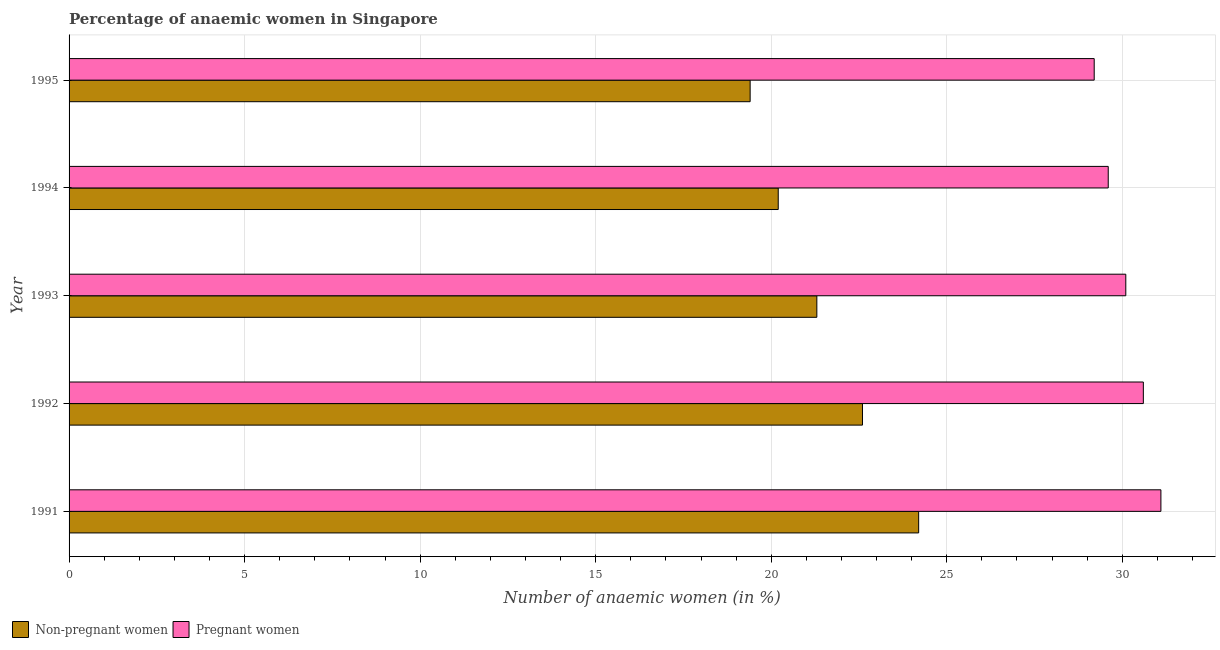How many different coloured bars are there?
Ensure brevity in your answer.  2. How many groups of bars are there?
Your answer should be very brief. 5. How many bars are there on the 4th tick from the bottom?
Offer a very short reply. 2. What is the label of the 4th group of bars from the top?
Your answer should be very brief. 1992. What is the percentage of non-pregnant anaemic women in 1995?
Offer a terse response. 19.4. Across all years, what is the maximum percentage of pregnant anaemic women?
Ensure brevity in your answer.  31.1. What is the total percentage of pregnant anaemic women in the graph?
Offer a very short reply. 150.6. What is the difference between the percentage of non-pregnant anaemic women in 1993 and that in 1995?
Your response must be concise. 1.9. What is the difference between the percentage of non-pregnant anaemic women in 1993 and the percentage of pregnant anaemic women in 1995?
Provide a short and direct response. -7.9. What is the average percentage of non-pregnant anaemic women per year?
Offer a very short reply. 21.54. What is the ratio of the percentage of non-pregnant anaemic women in 1992 to that in 1994?
Keep it short and to the point. 1.12. What is the difference between the highest and the second highest percentage of pregnant anaemic women?
Your answer should be compact. 0.5. What is the difference between the highest and the lowest percentage of non-pregnant anaemic women?
Your answer should be very brief. 4.8. What does the 1st bar from the top in 1994 represents?
Give a very brief answer. Pregnant women. What does the 1st bar from the bottom in 1992 represents?
Give a very brief answer. Non-pregnant women. Does the graph contain any zero values?
Provide a short and direct response. No. Where does the legend appear in the graph?
Make the answer very short. Bottom left. How many legend labels are there?
Offer a very short reply. 2. How are the legend labels stacked?
Keep it short and to the point. Horizontal. What is the title of the graph?
Your response must be concise. Percentage of anaemic women in Singapore. Does "Fixed telephone" appear as one of the legend labels in the graph?
Give a very brief answer. No. What is the label or title of the X-axis?
Ensure brevity in your answer.  Number of anaemic women (in %). What is the label or title of the Y-axis?
Ensure brevity in your answer.  Year. What is the Number of anaemic women (in %) in Non-pregnant women in 1991?
Give a very brief answer. 24.2. What is the Number of anaemic women (in %) in Pregnant women in 1991?
Ensure brevity in your answer.  31.1. What is the Number of anaemic women (in %) in Non-pregnant women in 1992?
Make the answer very short. 22.6. What is the Number of anaemic women (in %) in Pregnant women in 1992?
Provide a short and direct response. 30.6. What is the Number of anaemic women (in %) of Non-pregnant women in 1993?
Your response must be concise. 21.3. What is the Number of anaemic women (in %) of Pregnant women in 1993?
Provide a succinct answer. 30.1. What is the Number of anaemic women (in %) of Non-pregnant women in 1994?
Provide a succinct answer. 20.2. What is the Number of anaemic women (in %) in Pregnant women in 1994?
Your answer should be very brief. 29.6. What is the Number of anaemic women (in %) of Pregnant women in 1995?
Your answer should be very brief. 29.2. Across all years, what is the maximum Number of anaemic women (in %) of Non-pregnant women?
Ensure brevity in your answer.  24.2. Across all years, what is the maximum Number of anaemic women (in %) in Pregnant women?
Your answer should be very brief. 31.1. Across all years, what is the minimum Number of anaemic women (in %) in Pregnant women?
Offer a terse response. 29.2. What is the total Number of anaemic women (in %) of Non-pregnant women in the graph?
Ensure brevity in your answer.  107.7. What is the total Number of anaemic women (in %) in Pregnant women in the graph?
Your answer should be very brief. 150.6. What is the difference between the Number of anaemic women (in %) in Non-pregnant women in 1991 and that in 1992?
Your answer should be compact. 1.6. What is the difference between the Number of anaemic women (in %) of Non-pregnant women in 1991 and that in 1993?
Offer a very short reply. 2.9. What is the difference between the Number of anaemic women (in %) in Non-pregnant women in 1991 and that in 1994?
Your answer should be compact. 4. What is the difference between the Number of anaemic women (in %) of Pregnant women in 1991 and that in 1995?
Make the answer very short. 1.9. What is the difference between the Number of anaemic women (in %) in Pregnant women in 1992 and that in 1993?
Your answer should be compact. 0.5. What is the difference between the Number of anaemic women (in %) of Non-pregnant women in 1992 and that in 1995?
Your answer should be very brief. 3.2. What is the difference between the Number of anaemic women (in %) of Non-pregnant women in 1993 and that in 1995?
Keep it short and to the point. 1.9. What is the difference between the Number of anaemic women (in %) in Pregnant women in 1993 and that in 1995?
Your answer should be compact. 0.9. What is the difference between the Number of anaemic women (in %) in Non-pregnant women in 1994 and that in 1995?
Provide a short and direct response. 0.8. What is the difference between the Number of anaemic women (in %) of Pregnant women in 1994 and that in 1995?
Provide a short and direct response. 0.4. What is the difference between the Number of anaemic women (in %) of Non-pregnant women in 1991 and the Number of anaemic women (in %) of Pregnant women in 1995?
Provide a short and direct response. -5. What is the difference between the Number of anaemic women (in %) of Non-pregnant women in 1992 and the Number of anaemic women (in %) of Pregnant women in 1993?
Make the answer very short. -7.5. What is the difference between the Number of anaemic women (in %) of Non-pregnant women in 1992 and the Number of anaemic women (in %) of Pregnant women in 1994?
Provide a short and direct response. -7. What is the difference between the Number of anaemic women (in %) in Non-pregnant women in 1992 and the Number of anaemic women (in %) in Pregnant women in 1995?
Offer a very short reply. -6.6. What is the difference between the Number of anaemic women (in %) of Non-pregnant women in 1994 and the Number of anaemic women (in %) of Pregnant women in 1995?
Provide a succinct answer. -9. What is the average Number of anaemic women (in %) of Non-pregnant women per year?
Your answer should be compact. 21.54. What is the average Number of anaemic women (in %) in Pregnant women per year?
Keep it short and to the point. 30.12. In the year 1991, what is the difference between the Number of anaemic women (in %) of Non-pregnant women and Number of anaemic women (in %) of Pregnant women?
Your answer should be compact. -6.9. In the year 1992, what is the difference between the Number of anaemic women (in %) in Non-pregnant women and Number of anaemic women (in %) in Pregnant women?
Provide a short and direct response. -8. In the year 1994, what is the difference between the Number of anaemic women (in %) of Non-pregnant women and Number of anaemic women (in %) of Pregnant women?
Provide a succinct answer. -9.4. What is the ratio of the Number of anaemic women (in %) in Non-pregnant women in 1991 to that in 1992?
Keep it short and to the point. 1.07. What is the ratio of the Number of anaemic women (in %) in Pregnant women in 1991 to that in 1992?
Provide a short and direct response. 1.02. What is the ratio of the Number of anaemic women (in %) of Non-pregnant women in 1991 to that in 1993?
Offer a terse response. 1.14. What is the ratio of the Number of anaemic women (in %) in Pregnant women in 1991 to that in 1993?
Offer a very short reply. 1.03. What is the ratio of the Number of anaemic women (in %) in Non-pregnant women in 1991 to that in 1994?
Make the answer very short. 1.2. What is the ratio of the Number of anaemic women (in %) in Pregnant women in 1991 to that in 1994?
Keep it short and to the point. 1.05. What is the ratio of the Number of anaemic women (in %) of Non-pregnant women in 1991 to that in 1995?
Provide a short and direct response. 1.25. What is the ratio of the Number of anaemic women (in %) of Pregnant women in 1991 to that in 1995?
Make the answer very short. 1.07. What is the ratio of the Number of anaemic women (in %) in Non-pregnant women in 1992 to that in 1993?
Offer a terse response. 1.06. What is the ratio of the Number of anaemic women (in %) in Pregnant women in 1992 to that in 1993?
Provide a succinct answer. 1.02. What is the ratio of the Number of anaemic women (in %) of Non-pregnant women in 1992 to that in 1994?
Offer a terse response. 1.12. What is the ratio of the Number of anaemic women (in %) in Pregnant women in 1992 to that in 1994?
Your response must be concise. 1.03. What is the ratio of the Number of anaemic women (in %) of Non-pregnant women in 1992 to that in 1995?
Make the answer very short. 1.16. What is the ratio of the Number of anaemic women (in %) of Pregnant women in 1992 to that in 1995?
Offer a terse response. 1.05. What is the ratio of the Number of anaemic women (in %) in Non-pregnant women in 1993 to that in 1994?
Your response must be concise. 1.05. What is the ratio of the Number of anaemic women (in %) in Pregnant women in 1993 to that in 1994?
Make the answer very short. 1.02. What is the ratio of the Number of anaemic women (in %) in Non-pregnant women in 1993 to that in 1995?
Offer a very short reply. 1.1. What is the ratio of the Number of anaemic women (in %) of Pregnant women in 1993 to that in 1995?
Your answer should be compact. 1.03. What is the ratio of the Number of anaemic women (in %) in Non-pregnant women in 1994 to that in 1995?
Your response must be concise. 1.04. What is the ratio of the Number of anaemic women (in %) in Pregnant women in 1994 to that in 1995?
Keep it short and to the point. 1.01. What is the difference between the highest and the second highest Number of anaemic women (in %) in Pregnant women?
Make the answer very short. 0.5. What is the difference between the highest and the lowest Number of anaemic women (in %) in Pregnant women?
Give a very brief answer. 1.9. 